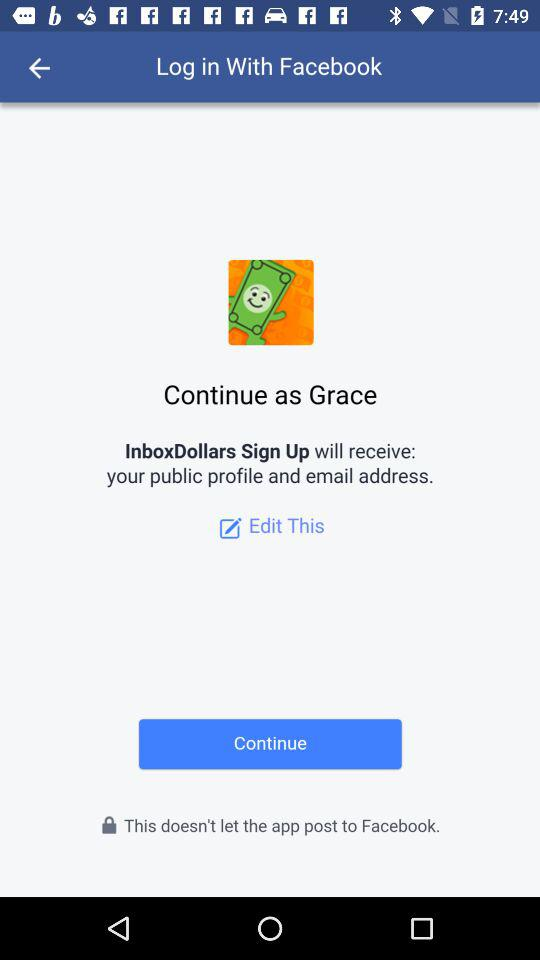What application will receive the public profile and email address? The public profile and email address will be received by "InboxDollars Sign Up". 